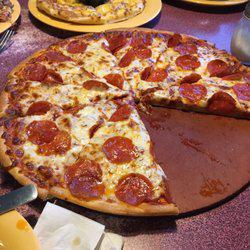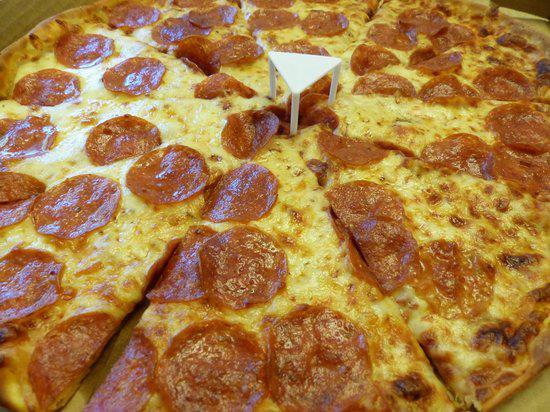The first image is the image on the left, the second image is the image on the right. Examine the images to the left and right. Is the description "All pizzas pictured are whole without any pieces missing or removed." accurate? Answer yes or no. No. 